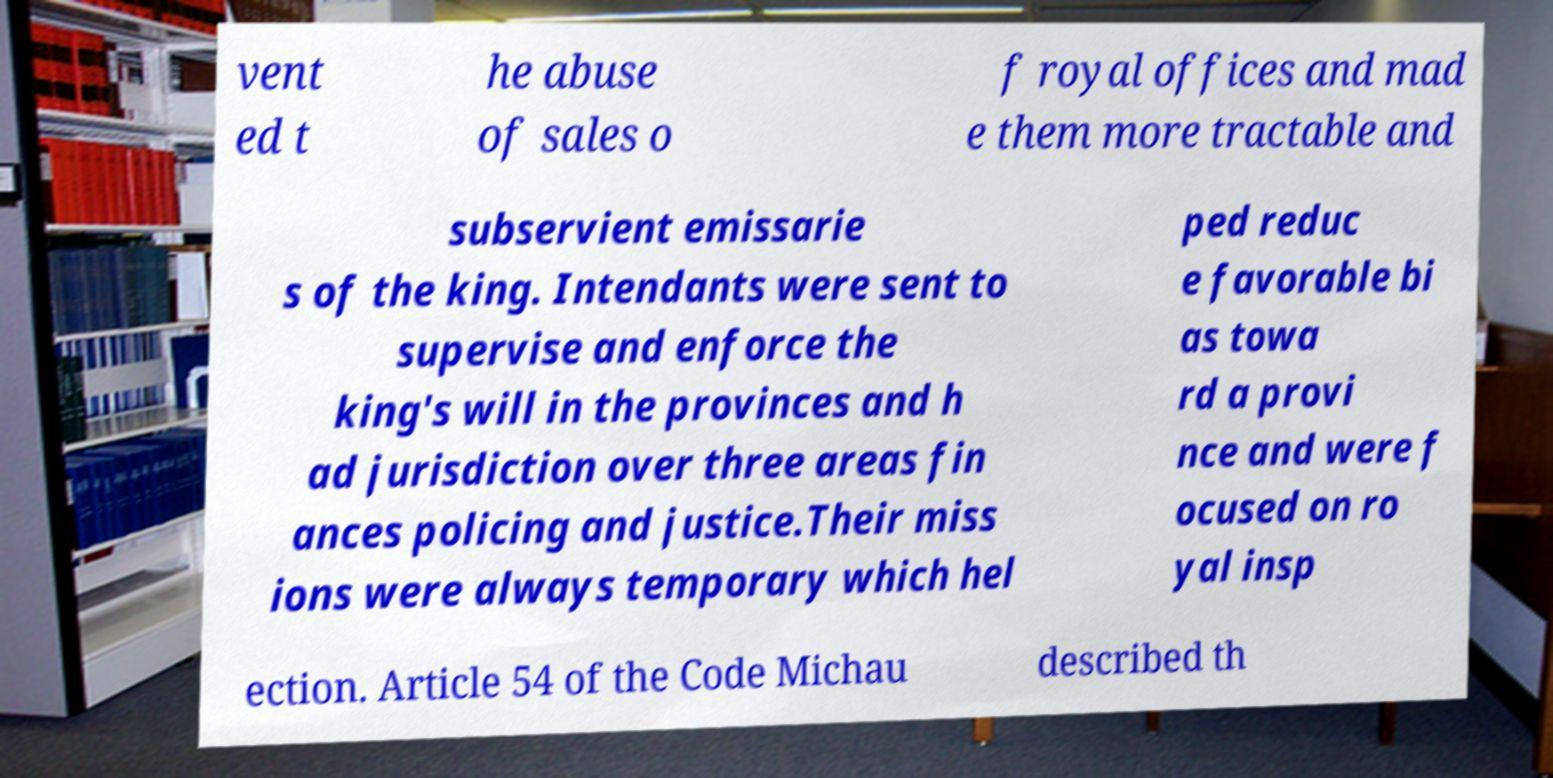For documentation purposes, I need the text within this image transcribed. Could you provide that? vent ed t he abuse of sales o f royal offices and mad e them more tractable and subservient emissarie s of the king. Intendants were sent to supervise and enforce the king's will in the provinces and h ad jurisdiction over three areas fin ances policing and justice.Their miss ions were always temporary which hel ped reduc e favorable bi as towa rd a provi nce and were f ocused on ro yal insp ection. Article 54 of the Code Michau described th 